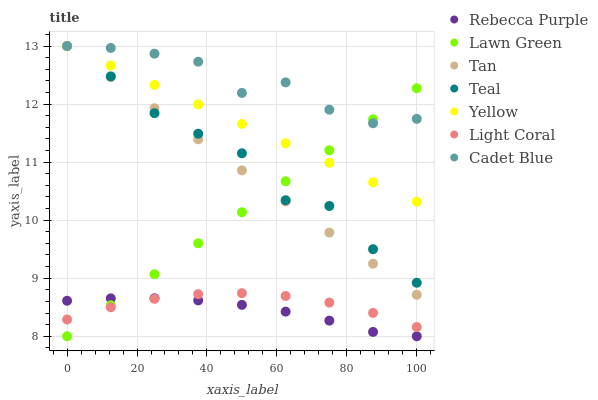Does Rebecca Purple have the minimum area under the curve?
Answer yes or no. Yes. Does Cadet Blue have the maximum area under the curve?
Answer yes or no. Yes. Does Yellow have the minimum area under the curve?
Answer yes or no. No. Does Yellow have the maximum area under the curve?
Answer yes or no. No. Is Tan the smoothest?
Answer yes or no. Yes. Is Cadet Blue the roughest?
Answer yes or no. Yes. Is Yellow the smoothest?
Answer yes or no. No. Is Yellow the roughest?
Answer yes or no. No. Does Lawn Green have the lowest value?
Answer yes or no. Yes. Does Yellow have the lowest value?
Answer yes or no. No. Does Tan have the highest value?
Answer yes or no. Yes. Does Light Coral have the highest value?
Answer yes or no. No. Is Light Coral less than Teal?
Answer yes or no. Yes. Is Yellow greater than Rebecca Purple?
Answer yes or no. Yes. Does Teal intersect Tan?
Answer yes or no. Yes. Is Teal less than Tan?
Answer yes or no. No. Is Teal greater than Tan?
Answer yes or no. No. Does Light Coral intersect Teal?
Answer yes or no. No. 